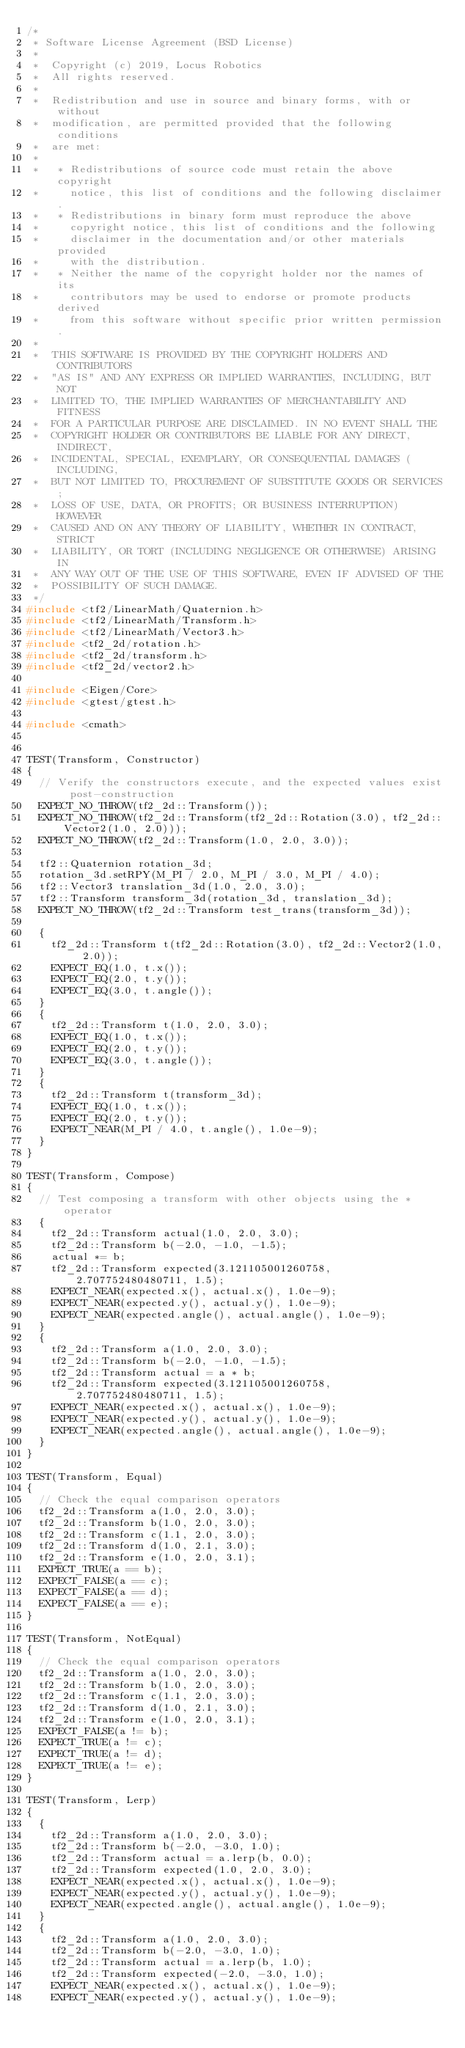Convert code to text. <code><loc_0><loc_0><loc_500><loc_500><_C++_>/*
 * Software License Agreement (BSD License)
 *
 *  Copyright (c) 2019, Locus Robotics
 *  All rights reserved.
 *
 *  Redistribution and use in source and binary forms, with or without
 *  modification, are permitted provided that the following conditions
 *  are met:
 *
 *   * Redistributions of source code must retain the above copyright
 *     notice, this list of conditions and the following disclaimer.
 *   * Redistributions in binary form must reproduce the above
 *     copyright notice, this list of conditions and the following
 *     disclaimer in the documentation and/or other materials provided
 *     with the distribution.
 *   * Neither the name of the copyright holder nor the names of its
 *     contributors may be used to endorse or promote products derived
 *     from this software without specific prior written permission.
 *
 *  THIS SOFTWARE IS PROVIDED BY THE COPYRIGHT HOLDERS AND CONTRIBUTORS
 *  "AS IS" AND ANY EXPRESS OR IMPLIED WARRANTIES, INCLUDING, BUT NOT
 *  LIMITED TO, THE IMPLIED WARRANTIES OF MERCHANTABILITY AND FITNESS
 *  FOR A PARTICULAR PURPOSE ARE DISCLAIMED. IN NO EVENT SHALL THE
 *  COPYRIGHT HOLDER OR CONTRIBUTORS BE LIABLE FOR ANY DIRECT, INDIRECT,
 *  INCIDENTAL, SPECIAL, EXEMPLARY, OR CONSEQUENTIAL DAMAGES (INCLUDING,
 *  BUT NOT LIMITED TO, PROCUREMENT OF SUBSTITUTE GOODS OR SERVICES;
 *  LOSS OF USE, DATA, OR PROFITS; OR BUSINESS INTERRUPTION) HOWEVER
 *  CAUSED AND ON ANY THEORY OF LIABILITY, WHETHER IN CONTRACT, STRICT
 *  LIABILITY, OR TORT (INCLUDING NEGLIGENCE OR OTHERWISE) ARISING IN
 *  ANY WAY OUT OF THE USE OF THIS SOFTWARE, EVEN IF ADVISED OF THE
 *  POSSIBILITY OF SUCH DAMAGE.
 */
#include <tf2/LinearMath/Quaternion.h>
#include <tf2/LinearMath/Transform.h>
#include <tf2/LinearMath/Vector3.h>
#include <tf2_2d/rotation.h>
#include <tf2_2d/transform.h>
#include <tf2_2d/vector2.h>

#include <Eigen/Core>
#include <gtest/gtest.h>

#include <cmath>


TEST(Transform, Constructor)
{
  // Verify the constructors execute, and the expected values exist post-construction
  EXPECT_NO_THROW(tf2_2d::Transform());
  EXPECT_NO_THROW(tf2_2d::Transform(tf2_2d::Rotation(3.0), tf2_2d::Vector2(1.0, 2.0)));
  EXPECT_NO_THROW(tf2_2d::Transform(1.0, 2.0, 3.0));

  tf2::Quaternion rotation_3d;
  rotation_3d.setRPY(M_PI / 2.0, M_PI / 3.0, M_PI / 4.0);
  tf2::Vector3 translation_3d(1.0, 2.0, 3.0);
  tf2::Transform transform_3d(rotation_3d, translation_3d);
  EXPECT_NO_THROW(tf2_2d::Transform test_trans(transform_3d));

  {
    tf2_2d::Transform t(tf2_2d::Rotation(3.0), tf2_2d::Vector2(1.0, 2.0));
    EXPECT_EQ(1.0, t.x());
    EXPECT_EQ(2.0, t.y());
    EXPECT_EQ(3.0, t.angle());
  }
  {
    tf2_2d::Transform t(1.0, 2.0, 3.0);
    EXPECT_EQ(1.0, t.x());
    EXPECT_EQ(2.0, t.y());
    EXPECT_EQ(3.0, t.angle());
  }
  {
    tf2_2d::Transform t(transform_3d);
    EXPECT_EQ(1.0, t.x());
    EXPECT_EQ(2.0, t.y());
    EXPECT_NEAR(M_PI / 4.0, t.angle(), 1.0e-9);
  }
}

TEST(Transform, Compose)
{
  // Test composing a transform with other objects using the * operator
  {
    tf2_2d::Transform actual(1.0, 2.0, 3.0);
    tf2_2d::Transform b(-2.0, -1.0, -1.5);
    actual *= b;
    tf2_2d::Transform expected(3.121105001260758, 2.707752480480711, 1.5);
    EXPECT_NEAR(expected.x(), actual.x(), 1.0e-9);
    EXPECT_NEAR(expected.y(), actual.y(), 1.0e-9);
    EXPECT_NEAR(expected.angle(), actual.angle(), 1.0e-9);
  }
  {
    tf2_2d::Transform a(1.0, 2.0, 3.0);
    tf2_2d::Transform b(-2.0, -1.0, -1.5);
    tf2_2d::Transform actual = a * b;
    tf2_2d::Transform expected(3.121105001260758, 2.707752480480711, 1.5);
    EXPECT_NEAR(expected.x(), actual.x(), 1.0e-9);
    EXPECT_NEAR(expected.y(), actual.y(), 1.0e-9);
    EXPECT_NEAR(expected.angle(), actual.angle(), 1.0e-9);
  }
}

TEST(Transform, Equal)
{
  // Check the equal comparison operators
  tf2_2d::Transform a(1.0, 2.0, 3.0);
  tf2_2d::Transform b(1.0, 2.0, 3.0);
  tf2_2d::Transform c(1.1, 2.0, 3.0);
  tf2_2d::Transform d(1.0, 2.1, 3.0);
  tf2_2d::Transform e(1.0, 2.0, 3.1);
  EXPECT_TRUE(a == b);
  EXPECT_FALSE(a == c);
  EXPECT_FALSE(a == d);
  EXPECT_FALSE(a == e);
}

TEST(Transform, NotEqual)
{
  // Check the equal comparison operators
  tf2_2d::Transform a(1.0, 2.0, 3.0);
  tf2_2d::Transform b(1.0, 2.0, 3.0);
  tf2_2d::Transform c(1.1, 2.0, 3.0);
  tf2_2d::Transform d(1.0, 2.1, 3.0);
  tf2_2d::Transform e(1.0, 2.0, 3.1);
  EXPECT_FALSE(a != b);
  EXPECT_TRUE(a != c);
  EXPECT_TRUE(a != d);
  EXPECT_TRUE(a != e);
}

TEST(Transform, Lerp)
{
  {
    tf2_2d::Transform a(1.0, 2.0, 3.0);
    tf2_2d::Transform b(-2.0, -3.0, 1.0);
    tf2_2d::Transform actual = a.lerp(b, 0.0);
    tf2_2d::Transform expected(1.0, 2.0, 3.0);
    EXPECT_NEAR(expected.x(), actual.x(), 1.0e-9);
    EXPECT_NEAR(expected.y(), actual.y(), 1.0e-9);
    EXPECT_NEAR(expected.angle(), actual.angle(), 1.0e-9);
  }
  {
    tf2_2d::Transform a(1.0, 2.0, 3.0);
    tf2_2d::Transform b(-2.0, -3.0, 1.0);
    tf2_2d::Transform actual = a.lerp(b, 1.0);
    tf2_2d::Transform expected(-2.0, -3.0, 1.0);
    EXPECT_NEAR(expected.x(), actual.x(), 1.0e-9);
    EXPECT_NEAR(expected.y(), actual.y(), 1.0e-9);</code> 